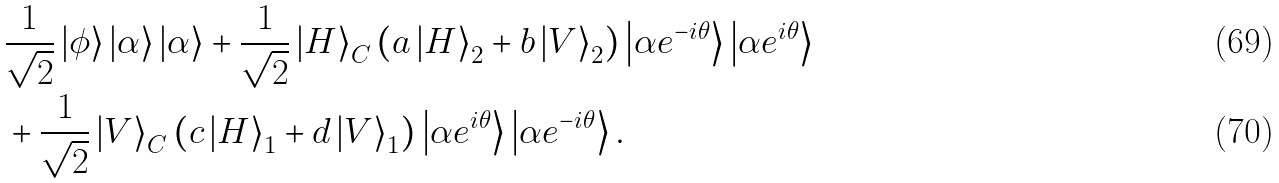<formula> <loc_0><loc_0><loc_500><loc_500>& \frac { 1 } { \sqrt { 2 } } \left | \phi \right \rangle \left | \alpha \right \rangle \left | \alpha \right \rangle + \frac { 1 } { \sqrt { 2 } } \left | H \right \rangle _ { C } \left ( a \left | H \right \rangle _ { 2 } + b \left | V \right \rangle _ { 2 } \right ) \left | \alpha e ^ { - i \theta } \right \rangle \left | \alpha e ^ { i \theta } \right \rangle \\ & + \frac { 1 } { \sqrt { 2 } } \left | V \right \rangle _ { C } \left ( c \left | H \right \rangle _ { 1 } + d \left | V \right \rangle _ { 1 } \right ) \left | \alpha e ^ { i \theta } \right \rangle \left | \alpha e ^ { - i \theta } \right \rangle .</formula> 